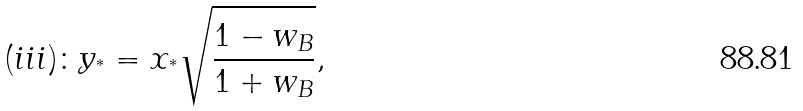<formula> <loc_0><loc_0><loc_500><loc_500>( i i i ) \colon y _ { ^ { * } } = x _ { ^ { * } } \sqrt { \frac { 1 - w _ { B } } { 1 + w _ { B } } } ,</formula> 